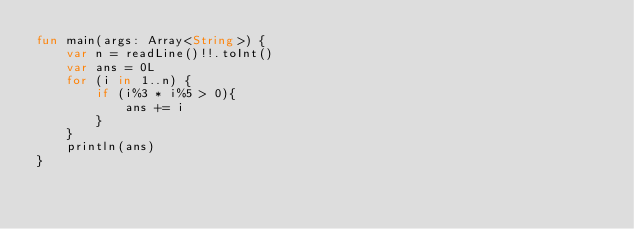<code> <loc_0><loc_0><loc_500><loc_500><_Kotlin_>fun main(args: Array<String>) {
    var n = readLine()!!.toInt()
    var ans = 0L
    for (i in 1..n) {
        if (i%3 * i%5 > 0){
            ans += i
        }
    }
    println(ans)
}
</code> 